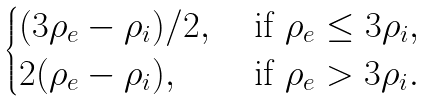<formula> <loc_0><loc_0><loc_500><loc_500>\begin{cases} ( 3 \rho _ { e } - \rho _ { i } ) / 2 , & \text { if } \rho _ { e } \leq 3 \rho _ { i } , \\ 2 ( \rho _ { e } - \rho _ { i } ) , & \text { if } \rho _ { e } > 3 \rho _ { i } . \end{cases}</formula> 